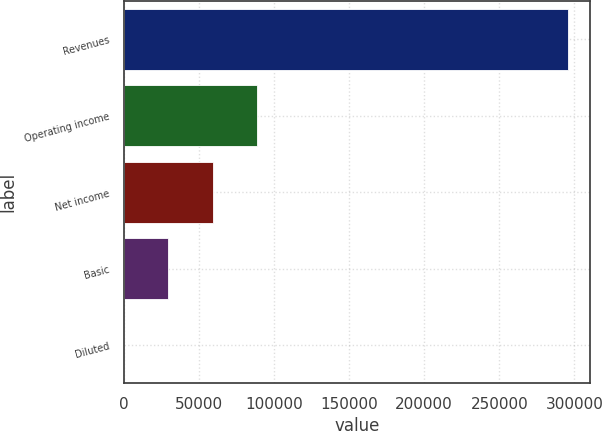Convert chart to OTSL. <chart><loc_0><loc_0><loc_500><loc_500><bar_chart><fcel>Revenues<fcel>Operating income<fcel>Net income<fcel>Basic<fcel>Diluted<nl><fcel>295833<fcel>88750<fcel>59166.8<fcel>29583.5<fcel>0.19<nl></chart> 